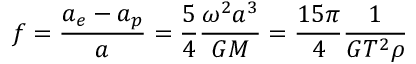Convert formula to latex. <formula><loc_0><loc_0><loc_500><loc_500>f = { \frac { a _ { e } - a _ { p } } { a } } = { \frac { 5 } { 4 } } { \frac { \omega ^ { 2 } a ^ { 3 } } { G M } } = { \frac { 1 5 \pi } { 4 } } { \frac { 1 } { G T ^ { 2 } \rho } }</formula> 